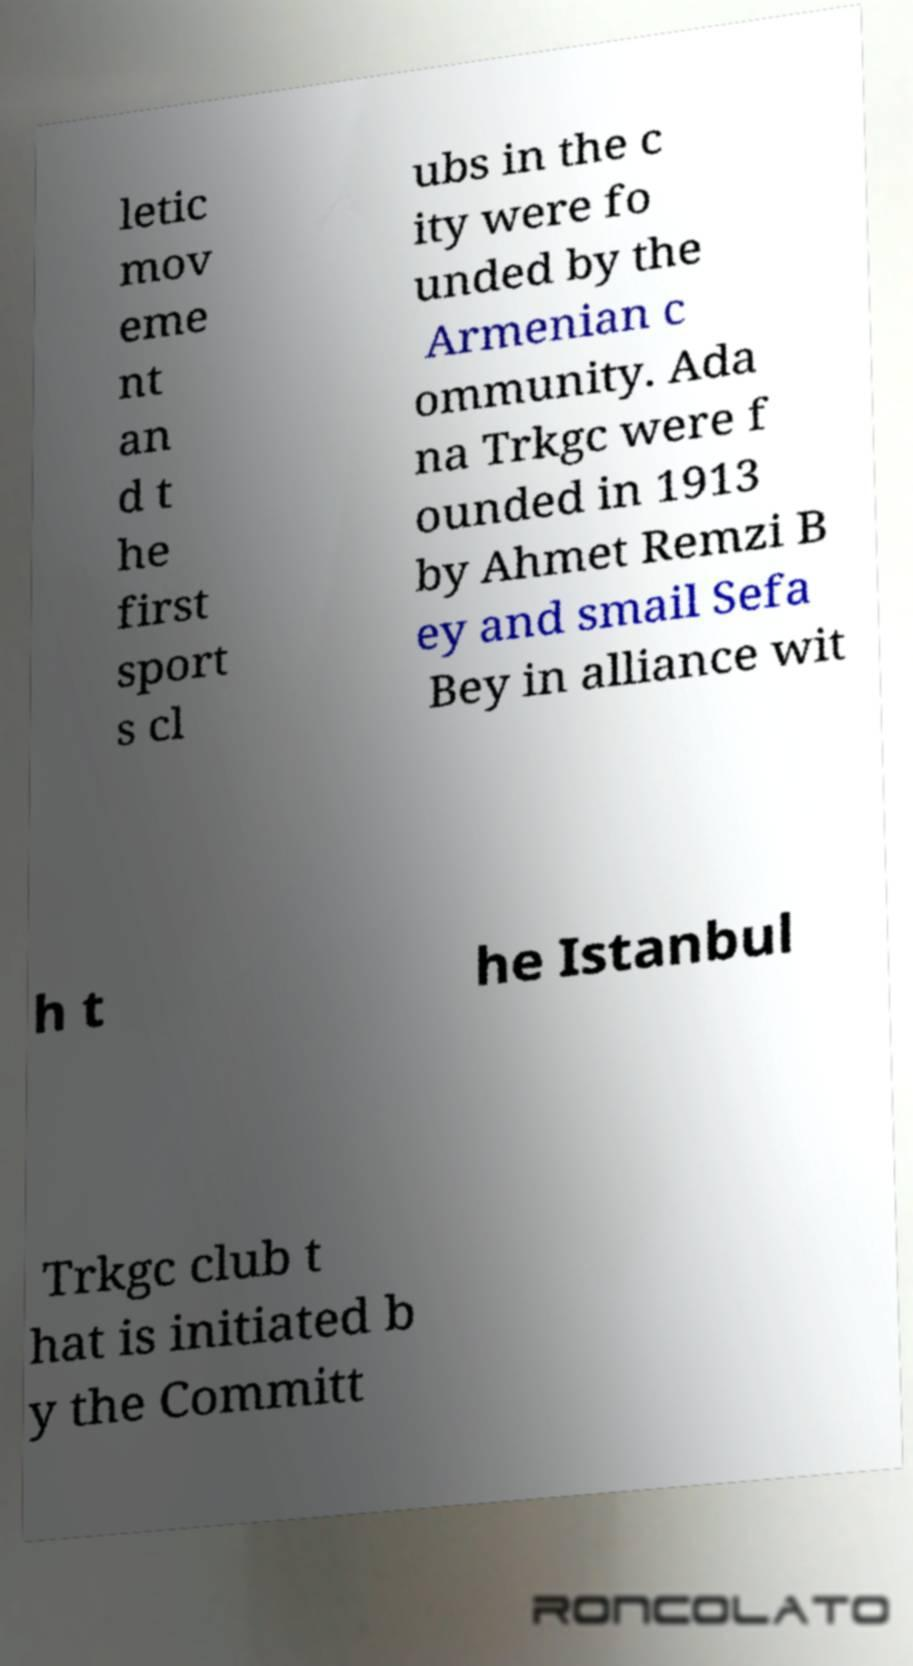I need the written content from this picture converted into text. Can you do that? letic mov eme nt an d t he first sport s cl ubs in the c ity were fo unded by the Armenian c ommunity. Ada na Trkgc were f ounded in 1913 by Ahmet Remzi B ey and smail Sefa Bey in alliance wit h t he Istanbul Trkgc club t hat is initiated b y the Committ 